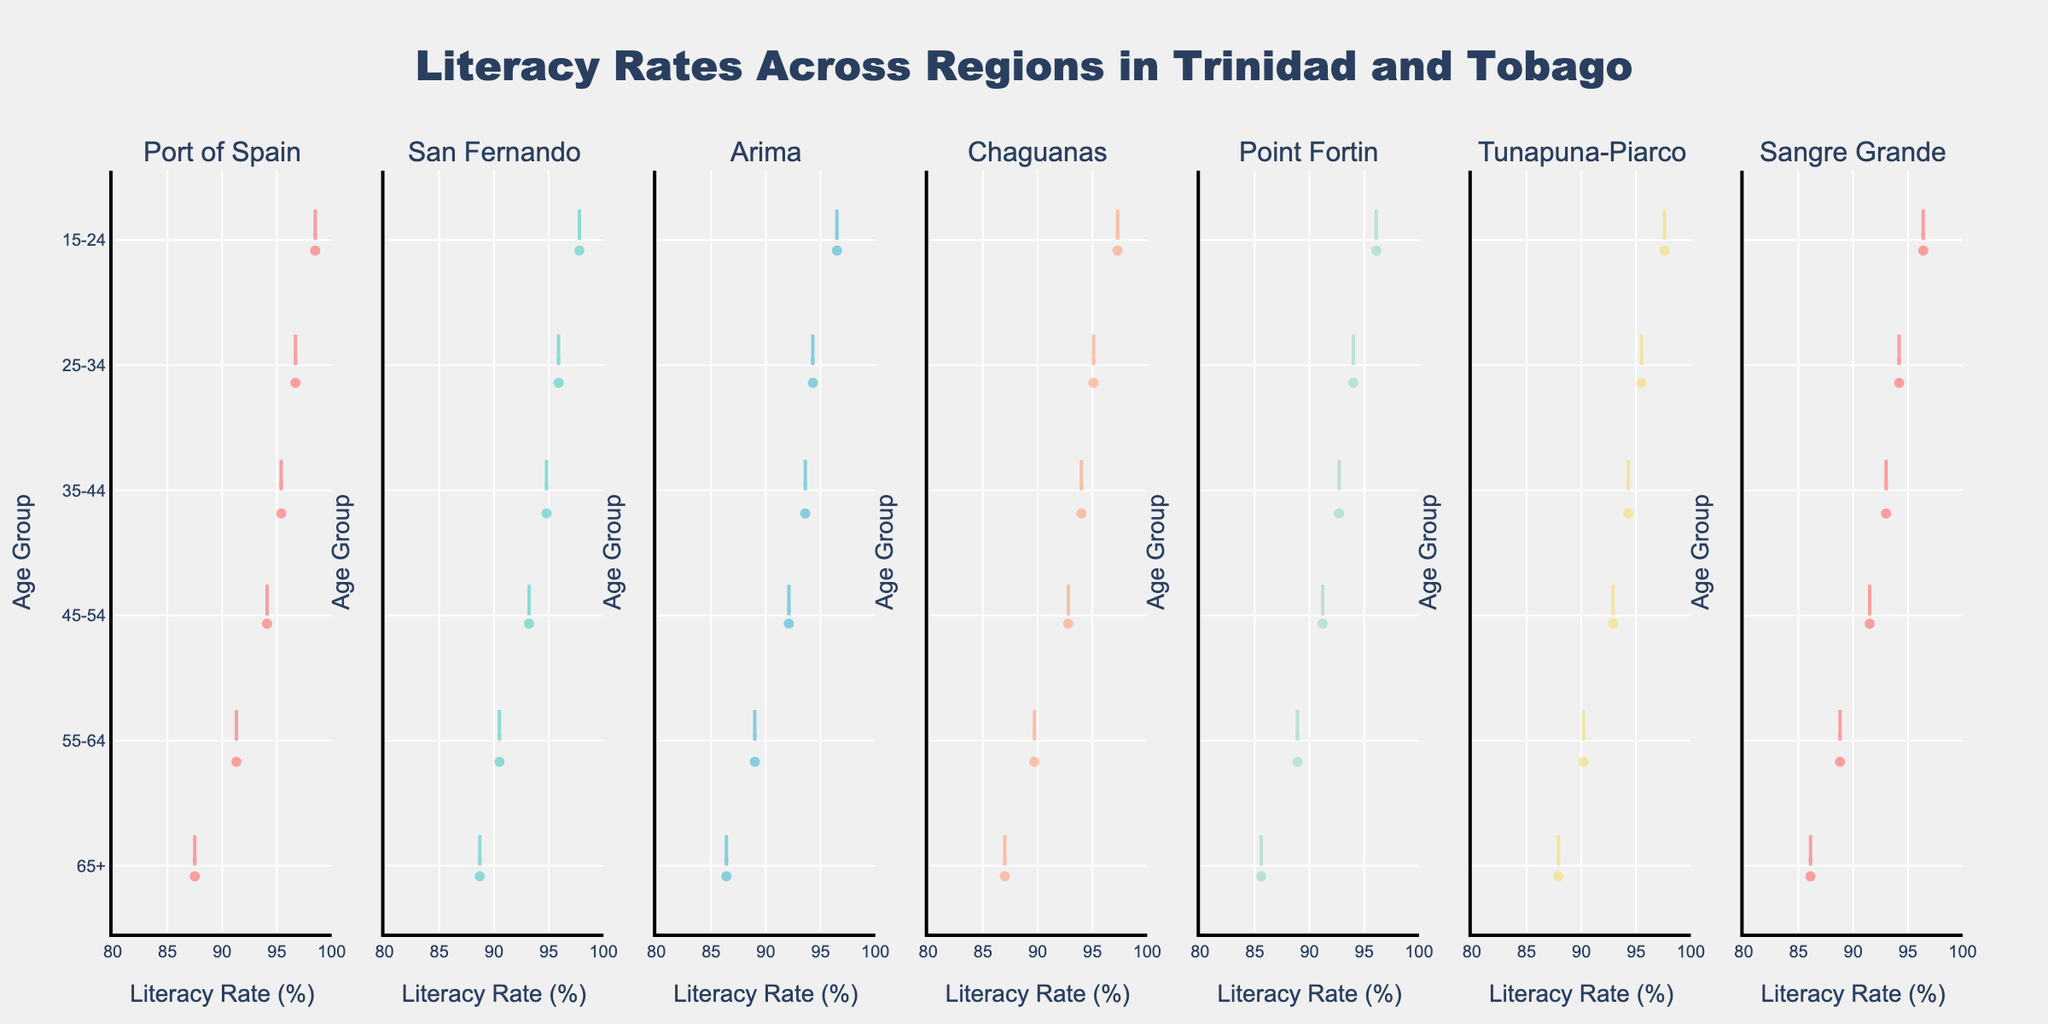What's the title of the chart? The title is displayed clearly at the top of the chart. It is "Literacy Rates Across Regions in Trinidad and Tobago".
Answer: Literacy Rates Across Regions in Trinidad and Tobago What is the age group with the highest literacy rate in Port of Spain? Observing the Port of Spain subplot, the age group 15-24 has the highest literacy rate.
Answer: 15-24 Which region has the lowest literacy rate for the 65+ age group? By comparing the 65+ age group across all regions, Point Fortin has the lowest literacy rate for this age group.
Answer: Point Fortin How many different regions are represented in the chart? By counting the subplot titles, it is evident that there are seven regions.
Answer: Seven Which age group shows the largest difference in literacy rates between Port of Spain and San Fernando? By examining the literacy rates across age groups for these two regions, the 15-24 age group has the largest difference (98.5% in Port of Spain and 97.8% in San Fernando).
Answer: 15-24 What is the overall trend in literacy rates as age increases for each region? The overall trend indicates that literacy rates generally decrease as age increases for all regions.
Answer: Decreasing Which region has the highest mean literacy rate? By comparing the mean lines on each subplot, Port of Spain has the highest mean literacy rate.
Answer: Port of Spain What is the literacy rate range observed in Tunapuna-Piarco? In the Tunapuna-Piarco subplot, the literacy rates range from about 87.9% to 97.6%.
Answer: 87.9% to 97.6% Which two regions have the most similar literacy rates for the 45-54 age group? Observing the 45-54 age group across regions, Chaguanas and Tunapuna-Piarco have nearly similar rates (92.8% and 92.9%, respectively).
Answer: Chaguanas and Tunapuna-Piarco Is there any region where the literacy rate for 55-64 is higher than for 45-54? Comparing these age groups in each region, there is no region where the literacy rate for 55-64 is higher than 45-54.
Answer: No 